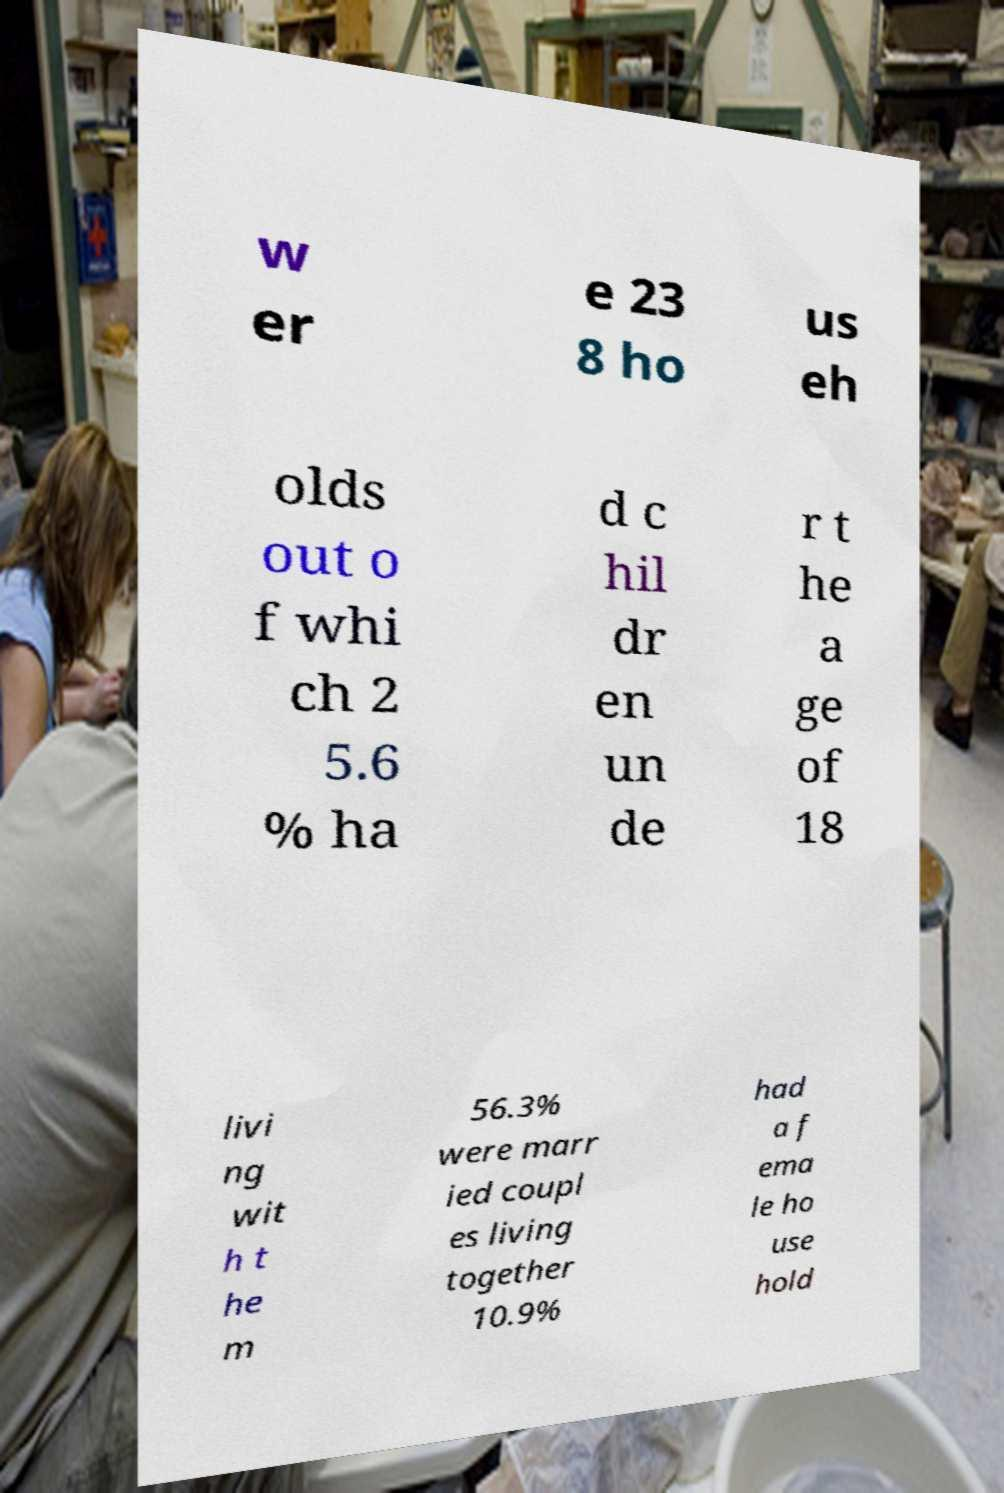I need the written content from this picture converted into text. Can you do that? w er e 23 8 ho us eh olds out o f whi ch 2 5.6 % ha d c hil dr en un de r t he a ge of 18 livi ng wit h t he m 56.3% were marr ied coupl es living together 10.9% had a f ema le ho use hold 